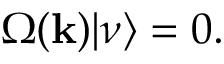<formula> <loc_0><loc_0><loc_500><loc_500>\Omega ( { k } ) | \nu \rangle = 0 .</formula> 